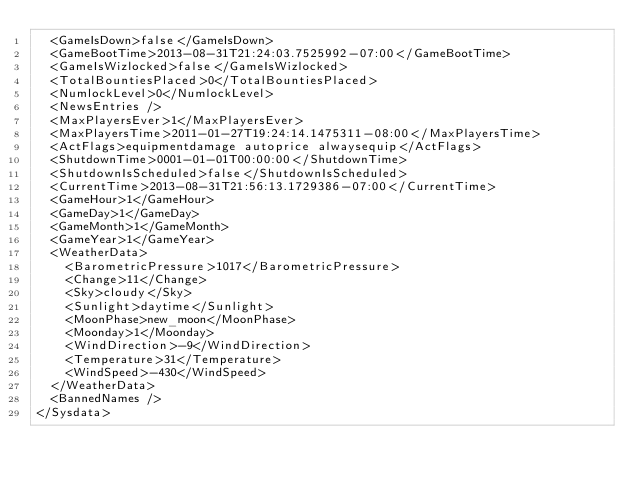<code> <loc_0><loc_0><loc_500><loc_500><_XML_>  <GameIsDown>false</GameIsDown>
  <GameBootTime>2013-08-31T21:24:03.7525992-07:00</GameBootTime>
  <GameIsWizlocked>false</GameIsWizlocked>
  <TotalBountiesPlaced>0</TotalBountiesPlaced>
  <NumlockLevel>0</NumlockLevel>
  <NewsEntries />
  <MaxPlayersEver>1</MaxPlayersEver>
  <MaxPlayersTime>2011-01-27T19:24:14.1475311-08:00</MaxPlayersTime>
  <ActFlags>equipmentdamage autoprice alwaysequip</ActFlags>
  <ShutdownTime>0001-01-01T00:00:00</ShutdownTime>
  <ShutdownIsScheduled>false</ShutdownIsScheduled>
  <CurrentTime>2013-08-31T21:56:13.1729386-07:00</CurrentTime>
  <GameHour>1</GameHour>
  <GameDay>1</GameDay>
  <GameMonth>1</GameMonth>
  <GameYear>1</GameYear>
  <WeatherData>
    <BarometricPressure>1017</BarometricPressure>
    <Change>11</Change>
    <Sky>cloudy</Sky>
    <Sunlight>daytime</Sunlight>
    <MoonPhase>new_moon</MoonPhase>
    <Moonday>1</Moonday>
    <WindDirection>-9</WindDirection>
    <Temperature>31</Temperature>
    <WindSpeed>-430</WindSpeed>
  </WeatherData>
  <BannedNames />
</Sysdata>
</code> 